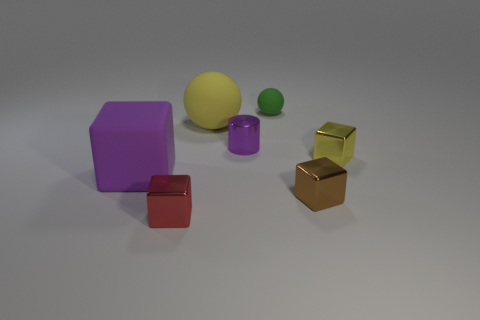Subtract all small metallic blocks. How many blocks are left? 1 Subtract all red cubes. How many cubes are left? 3 Add 3 small cubes. How many objects exist? 10 Subtract all cubes. How many objects are left? 3 Subtract all brown cylinders. Subtract all yellow blocks. How many cylinders are left? 1 Subtract all purple objects. Subtract all large cubes. How many objects are left? 4 Add 4 large things. How many large things are left? 6 Add 2 cyan objects. How many cyan objects exist? 2 Subtract 0 purple spheres. How many objects are left? 7 